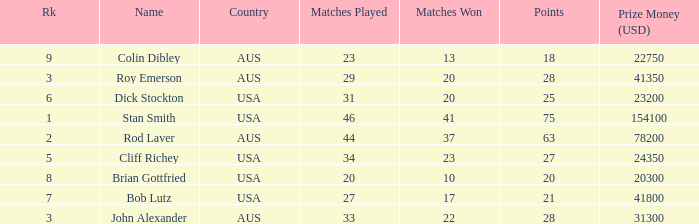How many matches did the player that played 23 matches win 13.0. 